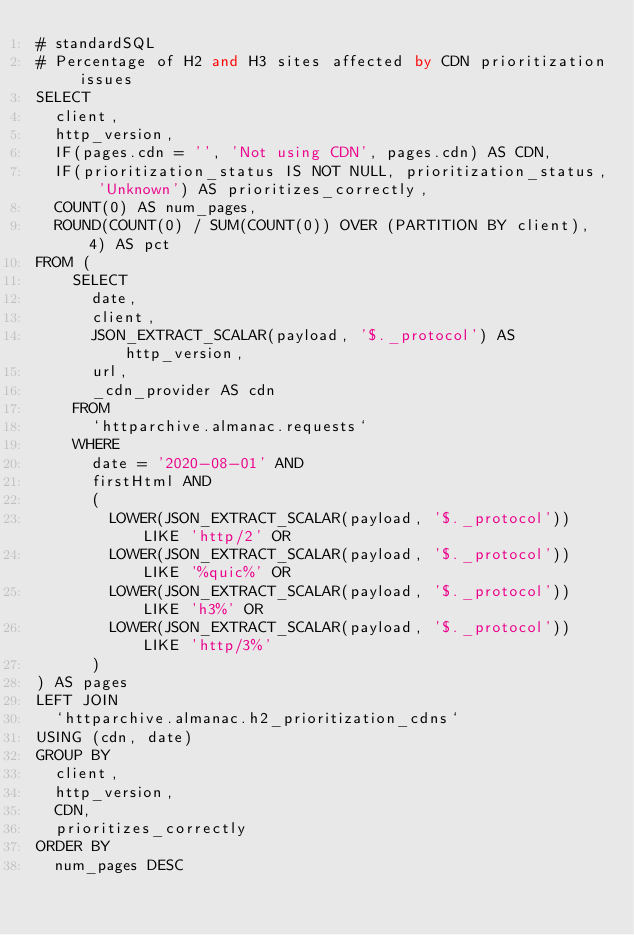<code> <loc_0><loc_0><loc_500><loc_500><_SQL_># standardSQL
# Percentage of H2 and H3 sites affected by CDN prioritization issues
SELECT
  client,
  http_version,
  IF(pages.cdn = '', 'Not using CDN', pages.cdn) AS CDN,
  IF(prioritization_status IS NOT NULL, prioritization_status, 'Unknown') AS prioritizes_correctly,
  COUNT(0) AS num_pages,
  ROUND(COUNT(0) / SUM(COUNT(0)) OVER (PARTITION BY client), 4) AS pct
FROM (
    SELECT
      date,
      client,
      JSON_EXTRACT_SCALAR(payload, '$._protocol') AS http_version,
      url,
      _cdn_provider AS cdn
    FROM
      `httparchive.almanac.requests`
    WHERE
      date = '2020-08-01' AND
      firstHtml AND
      (
        LOWER(JSON_EXTRACT_SCALAR(payload, '$._protocol')) LIKE 'http/2' OR
        LOWER(JSON_EXTRACT_SCALAR(payload, '$._protocol')) LIKE '%quic%' OR
        LOWER(JSON_EXTRACT_SCALAR(payload, '$._protocol')) LIKE 'h3%' OR
        LOWER(JSON_EXTRACT_SCALAR(payload, '$._protocol')) LIKE 'http/3%'
      )
) AS pages
LEFT JOIN
  `httparchive.almanac.h2_prioritization_cdns`
USING (cdn, date)
GROUP BY
  client,
  http_version,
  CDN,
  prioritizes_correctly
ORDER BY
  num_pages DESC
</code> 